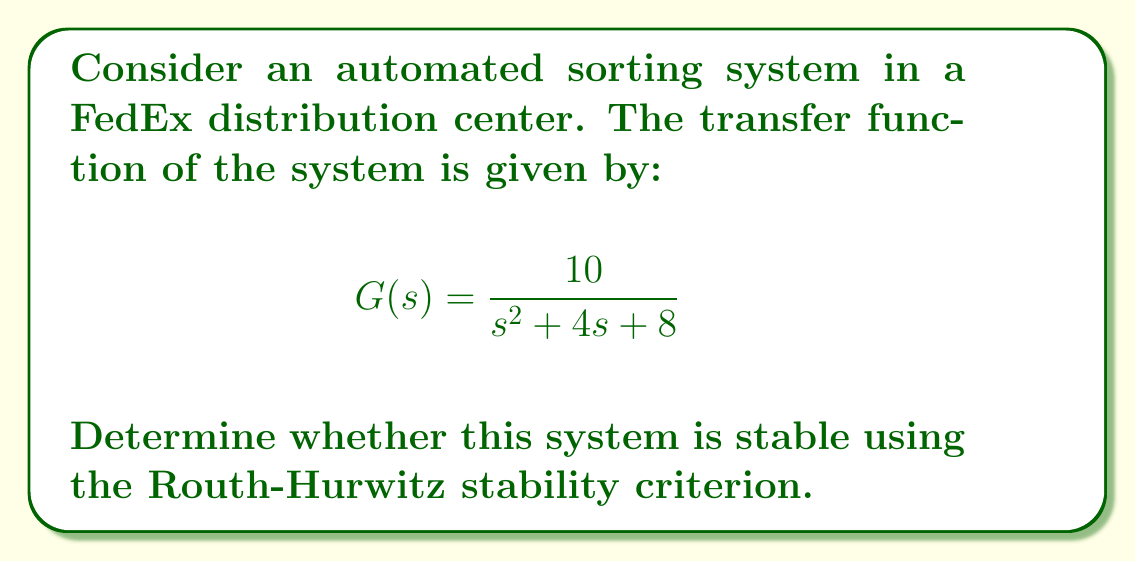Teach me how to tackle this problem. To determine the stability of the system using the Routh-Hurwitz criterion, we follow these steps:

1) First, we identify the characteristic equation from the transfer function:
   $$s^2 + 4s + 8 = 0$$

2) We create the Routh array:
   $$\begin{array}{c|c}
   s^2 & 1 & 8 \\
   s^1 & 4 & 0 \\
   s^0 & 8 & 
   \end{array}$$

3) We calculate the elements of the array:
   - The first two rows are coefficients from the characteristic equation.
   - The third row is calculated as follows:
     $$8 = \frac{(4)(8) - (1)(0)}{4} = 8$$

4) We examine the first column of the Routh array:
   $$\begin{array}{c|c}
   s^2 & 1 \\
   s^1 & 4 \\
   s^0 & 8
   \end{array}$$

5) For stability, all elements in the first column must have the same sign (all positive or all negative).

6) In this case, all elements in the first column (1, 4, and 8) are positive.

Therefore, according to the Routh-Hurwitz stability criterion, the system is stable.
Answer: Stable 